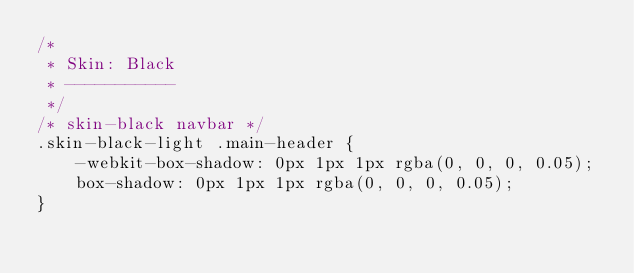<code> <loc_0><loc_0><loc_500><loc_500><_CSS_>/*
 * Skin: Black
 * -----------
 */
/* skin-black navbar */
.skin-black-light .main-header {
    -webkit-box-shadow: 0px 1px 1px rgba(0, 0, 0, 0.05);
    box-shadow: 0px 1px 1px rgba(0, 0, 0, 0.05);
}</code> 